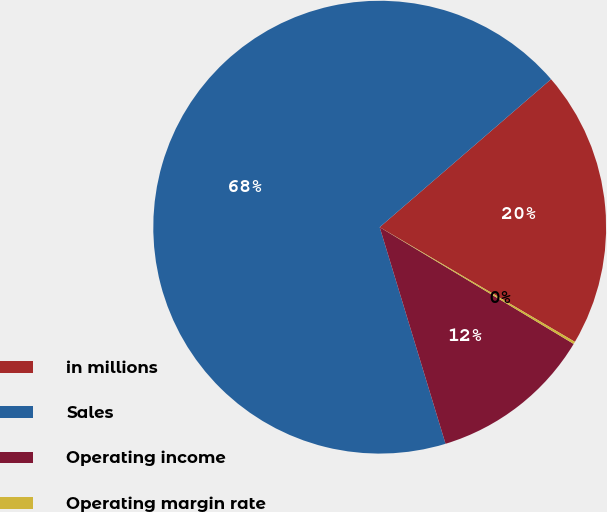Convert chart to OTSL. <chart><loc_0><loc_0><loc_500><loc_500><pie_chart><fcel>in millions<fcel>Sales<fcel>Operating income<fcel>Operating margin rate<nl><fcel>19.79%<fcel>68.36%<fcel>11.68%<fcel>0.17%<nl></chart> 